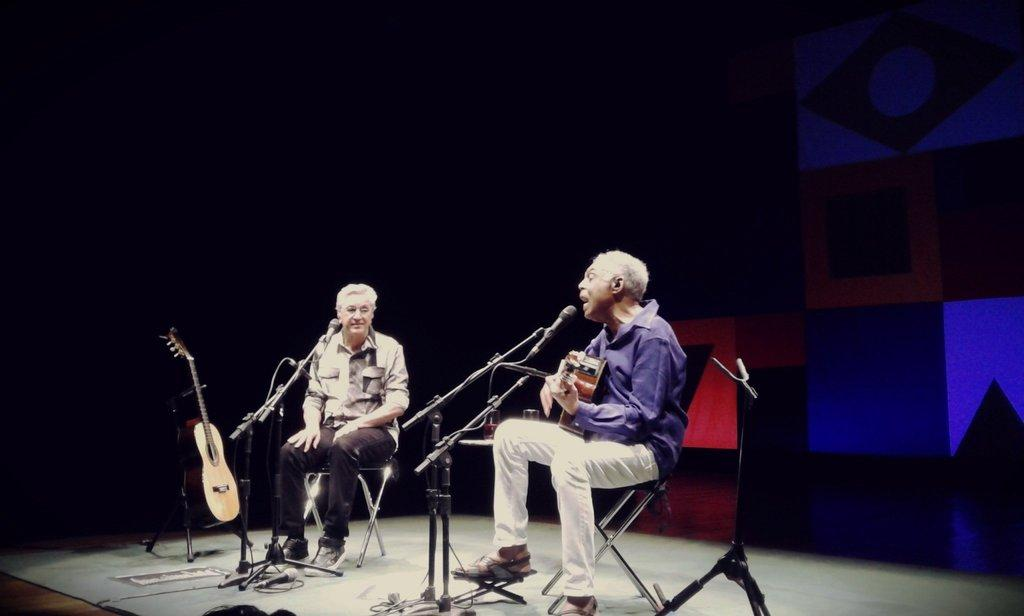What is the man in the foreground of the image doing? The man in the foreground is sitting in a chair. What is the other man in the image doing? The other man is sitting and playing a guitar. Can you describe the guitar in the image? There is a guitar kept in a stand in the background of the image. What type of powder can be seen falling from the ceiling in the image? There is no powder falling from the ceiling in the image. 